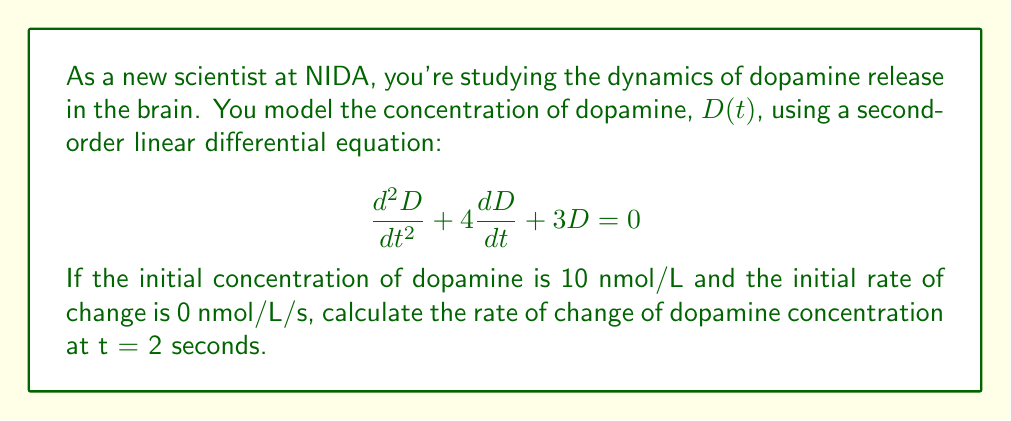Help me with this question. To solve this problem, we'll follow these steps:

1) The general solution for this second-order linear differential equation is:

   $$D(t) = c_1e^{-t} + c_2e^{-3t}$$

2) We need to find $c_1$ and $c_2$ using the initial conditions:
   
   At $t = 0$, $D(0) = 10$ and $D'(0) = 0$

3) Using $D(0) = 10$:
   
   $$10 = c_1 + c_2$$

4) Using $D'(0) = 0$:
   
   $$D'(t) = -c_1e^{-t} - 3c_2e^{-3t}$$
   $$0 = -c_1 - 3c_2$$

5) Solving these equations:
   
   $c_1 = 7.5$ and $c_2 = 2.5$

6) So, our solution is:

   $$D(t) = 7.5e^{-t} + 2.5e^{-3t}$$

7) To find the rate of change at $t = 2$, we need to calculate $D'(2)$:

   $$D'(t) = -7.5e^{-t} - 7.5e^{-3t}$$
   $$D'(2) = -7.5e^{-2} - 7.5e^{-6}$$

8) Calculate the numerical value:

   $$D'(2) = -7.5(0.1353) - 7.5(0.0025) = -1.0148 - 0.0188 = -1.0336$$
Answer: The rate of change of dopamine concentration at t = 2 seconds is approximately -1.0336 nmol/L/s. 